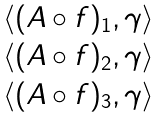Convert formula to latex. <formula><loc_0><loc_0><loc_500><loc_500>\begin{matrix} \langle ( A \circ f ) _ { 1 } , \gamma \rangle \\ \langle ( A \circ f ) _ { 2 } , \gamma \rangle \\ \langle ( A \circ f ) _ { 3 } , \gamma \rangle \end{matrix}</formula> 